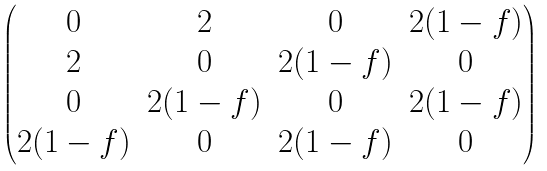<formula> <loc_0><loc_0><loc_500><loc_500>\begin{pmatrix} 0 & 2 & 0 & 2 ( 1 - f ) \\ 2 & 0 & 2 ( 1 - f ) & 0 \\ 0 & 2 ( 1 - f ) & 0 & 2 ( 1 - f ) \\ 2 ( 1 - f ) & 0 & 2 ( 1 - f ) & 0 \\ \end{pmatrix}</formula> 